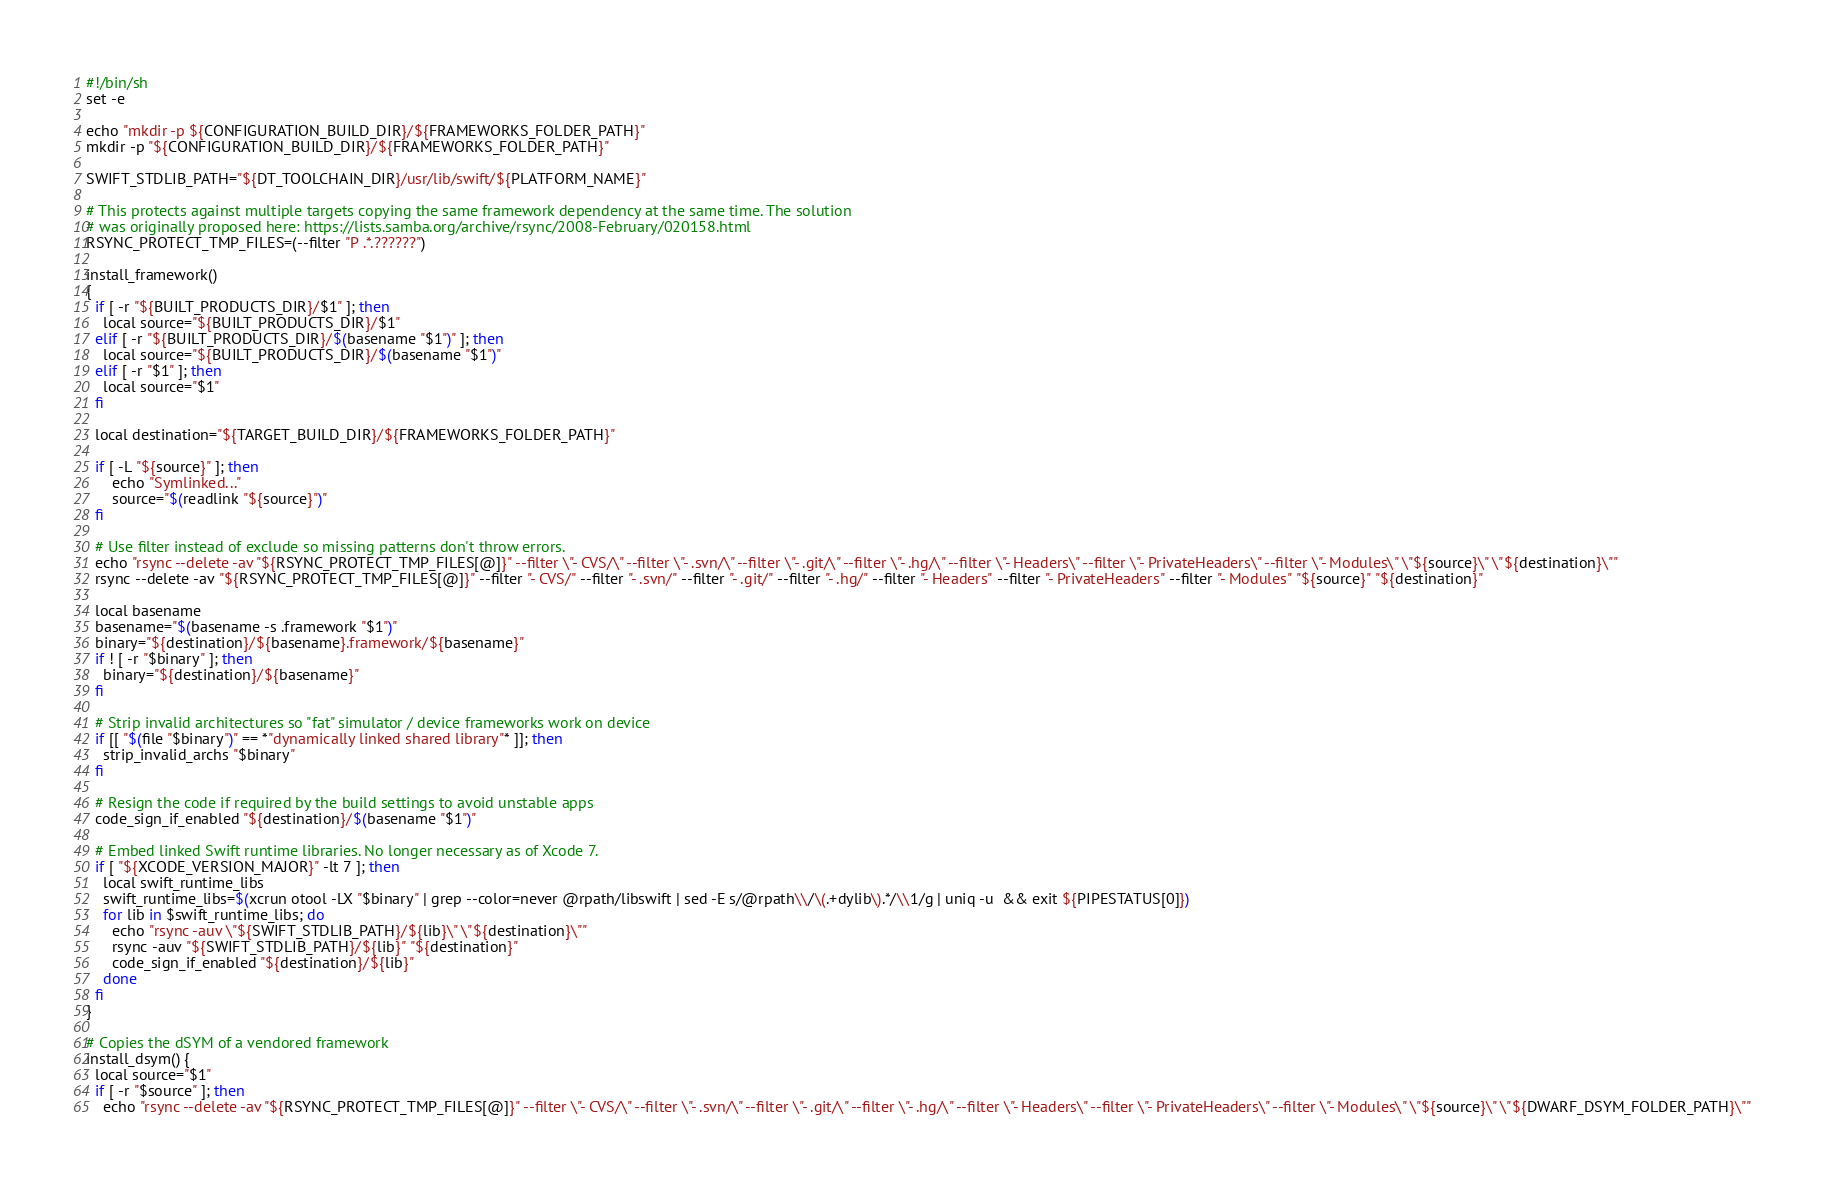<code> <loc_0><loc_0><loc_500><loc_500><_Bash_>#!/bin/sh
set -e

echo "mkdir -p ${CONFIGURATION_BUILD_DIR}/${FRAMEWORKS_FOLDER_PATH}"
mkdir -p "${CONFIGURATION_BUILD_DIR}/${FRAMEWORKS_FOLDER_PATH}"

SWIFT_STDLIB_PATH="${DT_TOOLCHAIN_DIR}/usr/lib/swift/${PLATFORM_NAME}"

# This protects against multiple targets copying the same framework dependency at the same time. The solution
# was originally proposed here: https://lists.samba.org/archive/rsync/2008-February/020158.html
RSYNC_PROTECT_TMP_FILES=(--filter "P .*.??????")

install_framework()
{
  if [ -r "${BUILT_PRODUCTS_DIR}/$1" ]; then
    local source="${BUILT_PRODUCTS_DIR}/$1"
  elif [ -r "${BUILT_PRODUCTS_DIR}/$(basename "$1")" ]; then
    local source="${BUILT_PRODUCTS_DIR}/$(basename "$1")"
  elif [ -r "$1" ]; then
    local source="$1"
  fi

  local destination="${TARGET_BUILD_DIR}/${FRAMEWORKS_FOLDER_PATH}"

  if [ -L "${source}" ]; then
      echo "Symlinked..."
      source="$(readlink "${source}")"
  fi

  # Use filter instead of exclude so missing patterns don't throw errors.
  echo "rsync --delete -av "${RSYNC_PROTECT_TMP_FILES[@]}" --filter \"- CVS/\" --filter \"- .svn/\" --filter \"- .git/\" --filter \"- .hg/\" --filter \"- Headers\" --filter \"- PrivateHeaders\" --filter \"- Modules\" \"${source}\" \"${destination}\""
  rsync --delete -av "${RSYNC_PROTECT_TMP_FILES[@]}" --filter "- CVS/" --filter "- .svn/" --filter "- .git/" --filter "- .hg/" --filter "- Headers" --filter "- PrivateHeaders" --filter "- Modules" "${source}" "${destination}"

  local basename
  basename="$(basename -s .framework "$1")"
  binary="${destination}/${basename}.framework/${basename}"
  if ! [ -r "$binary" ]; then
    binary="${destination}/${basename}"
  fi

  # Strip invalid architectures so "fat" simulator / device frameworks work on device
  if [[ "$(file "$binary")" == *"dynamically linked shared library"* ]]; then
    strip_invalid_archs "$binary"
  fi

  # Resign the code if required by the build settings to avoid unstable apps
  code_sign_if_enabled "${destination}/$(basename "$1")"

  # Embed linked Swift runtime libraries. No longer necessary as of Xcode 7.
  if [ "${XCODE_VERSION_MAJOR}" -lt 7 ]; then
    local swift_runtime_libs
    swift_runtime_libs=$(xcrun otool -LX "$binary" | grep --color=never @rpath/libswift | sed -E s/@rpath\\/\(.+dylib\).*/\\1/g | uniq -u  && exit ${PIPESTATUS[0]})
    for lib in $swift_runtime_libs; do
      echo "rsync -auv \"${SWIFT_STDLIB_PATH}/${lib}\" \"${destination}\""
      rsync -auv "${SWIFT_STDLIB_PATH}/${lib}" "${destination}"
      code_sign_if_enabled "${destination}/${lib}"
    done
  fi
}

# Copies the dSYM of a vendored framework
install_dsym() {
  local source="$1"
  if [ -r "$source" ]; then
    echo "rsync --delete -av "${RSYNC_PROTECT_TMP_FILES[@]}" --filter \"- CVS/\" --filter \"- .svn/\" --filter \"- .git/\" --filter \"- .hg/\" --filter \"- Headers\" --filter \"- PrivateHeaders\" --filter \"- Modules\" \"${source}\" \"${DWARF_DSYM_FOLDER_PATH}\""</code> 